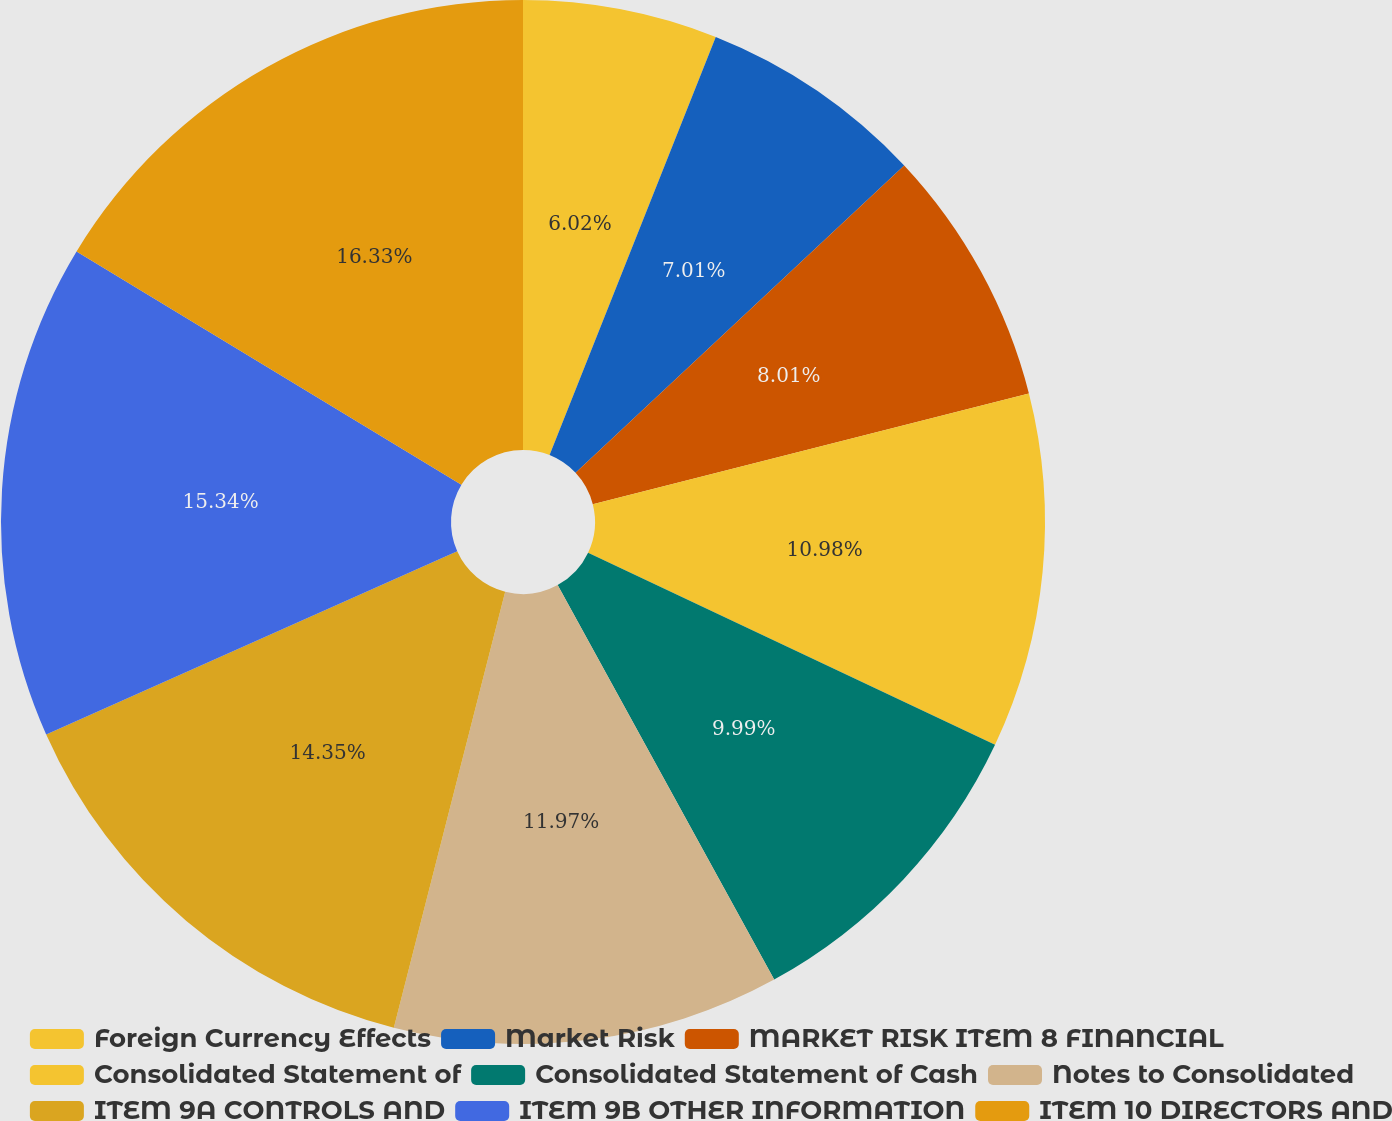Convert chart to OTSL. <chart><loc_0><loc_0><loc_500><loc_500><pie_chart><fcel>Foreign Currency Effects<fcel>Market Risk<fcel>MARKET RISK ITEM 8 FINANCIAL<fcel>Consolidated Statement of<fcel>Consolidated Statement of Cash<fcel>Notes to Consolidated<fcel>ITEM 9A CONTROLS AND<fcel>ITEM 9B OTHER INFORMATION<fcel>ITEM 10 DIRECTORS AND<nl><fcel>6.02%<fcel>7.01%<fcel>8.01%<fcel>10.98%<fcel>9.99%<fcel>11.97%<fcel>14.35%<fcel>15.34%<fcel>16.33%<nl></chart> 